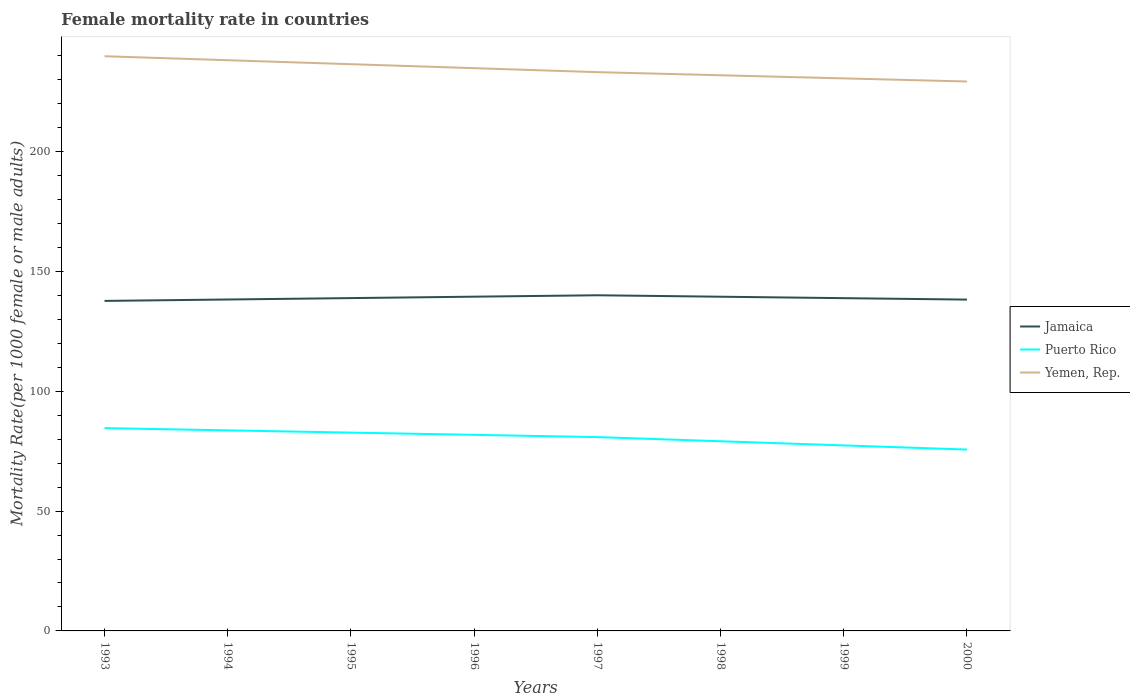Is the number of lines equal to the number of legend labels?
Give a very brief answer. Yes. Across all years, what is the maximum female mortality rate in Jamaica?
Ensure brevity in your answer.  137.72. In which year was the female mortality rate in Puerto Rico maximum?
Ensure brevity in your answer.  2000. What is the total female mortality rate in Jamaica in the graph?
Offer a very short reply. -0.54. What is the difference between the highest and the second highest female mortality rate in Jamaica?
Ensure brevity in your answer.  2.35. How many years are there in the graph?
Your answer should be very brief. 8. What is the difference between two consecutive major ticks on the Y-axis?
Provide a short and direct response. 50. Does the graph contain any zero values?
Provide a succinct answer. No. How many legend labels are there?
Offer a very short reply. 3. How are the legend labels stacked?
Your response must be concise. Vertical. What is the title of the graph?
Your answer should be very brief. Female mortality rate in countries. Does "Mexico" appear as one of the legend labels in the graph?
Your answer should be compact. No. What is the label or title of the X-axis?
Keep it short and to the point. Years. What is the label or title of the Y-axis?
Ensure brevity in your answer.  Mortality Rate(per 1000 female or male adults). What is the Mortality Rate(per 1000 female or male adults) of Jamaica in 1993?
Your answer should be compact. 137.72. What is the Mortality Rate(per 1000 female or male adults) in Puerto Rico in 1993?
Give a very brief answer. 84.63. What is the Mortality Rate(per 1000 female or male adults) of Yemen, Rep. in 1993?
Your response must be concise. 239.82. What is the Mortality Rate(per 1000 female or male adults) of Jamaica in 1994?
Your answer should be compact. 138.31. What is the Mortality Rate(per 1000 female or male adults) in Puerto Rico in 1994?
Give a very brief answer. 83.7. What is the Mortality Rate(per 1000 female or male adults) in Yemen, Rep. in 1994?
Offer a terse response. 238.16. What is the Mortality Rate(per 1000 female or male adults) in Jamaica in 1995?
Make the answer very short. 138.89. What is the Mortality Rate(per 1000 female or male adults) in Puerto Rico in 1995?
Your response must be concise. 82.76. What is the Mortality Rate(per 1000 female or male adults) of Yemen, Rep. in 1995?
Ensure brevity in your answer.  236.5. What is the Mortality Rate(per 1000 female or male adults) of Jamaica in 1996?
Offer a terse response. 139.48. What is the Mortality Rate(per 1000 female or male adults) in Puerto Rico in 1996?
Offer a very short reply. 81.82. What is the Mortality Rate(per 1000 female or male adults) of Yemen, Rep. in 1996?
Ensure brevity in your answer.  234.84. What is the Mortality Rate(per 1000 female or male adults) of Jamaica in 1997?
Your response must be concise. 140.07. What is the Mortality Rate(per 1000 female or male adults) of Puerto Rico in 1997?
Give a very brief answer. 80.89. What is the Mortality Rate(per 1000 female or male adults) of Yemen, Rep. in 1997?
Keep it short and to the point. 233.18. What is the Mortality Rate(per 1000 female or male adults) of Jamaica in 1998?
Offer a terse response. 139.47. What is the Mortality Rate(per 1000 female or male adults) in Puerto Rico in 1998?
Provide a short and direct response. 79.15. What is the Mortality Rate(per 1000 female or male adults) of Yemen, Rep. in 1998?
Provide a succinct answer. 231.88. What is the Mortality Rate(per 1000 female or male adults) in Jamaica in 1999?
Keep it short and to the point. 138.87. What is the Mortality Rate(per 1000 female or male adults) of Puerto Rico in 1999?
Your answer should be very brief. 77.42. What is the Mortality Rate(per 1000 female or male adults) of Yemen, Rep. in 1999?
Provide a succinct answer. 230.58. What is the Mortality Rate(per 1000 female or male adults) of Jamaica in 2000?
Ensure brevity in your answer.  138.26. What is the Mortality Rate(per 1000 female or male adults) of Puerto Rico in 2000?
Your response must be concise. 75.68. What is the Mortality Rate(per 1000 female or male adults) of Yemen, Rep. in 2000?
Offer a terse response. 229.28. Across all years, what is the maximum Mortality Rate(per 1000 female or male adults) of Jamaica?
Provide a short and direct response. 140.07. Across all years, what is the maximum Mortality Rate(per 1000 female or male adults) in Puerto Rico?
Make the answer very short. 84.63. Across all years, what is the maximum Mortality Rate(per 1000 female or male adults) in Yemen, Rep.?
Offer a very short reply. 239.82. Across all years, what is the minimum Mortality Rate(per 1000 female or male adults) in Jamaica?
Your answer should be compact. 137.72. Across all years, what is the minimum Mortality Rate(per 1000 female or male adults) in Puerto Rico?
Provide a short and direct response. 75.68. Across all years, what is the minimum Mortality Rate(per 1000 female or male adults) in Yemen, Rep.?
Ensure brevity in your answer.  229.28. What is the total Mortality Rate(per 1000 female or male adults) in Jamaica in the graph?
Your response must be concise. 1111.07. What is the total Mortality Rate(per 1000 female or male adults) in Puerto Rico in the graph?
Your answer should be compact. 646.04. What is the total Mortality Rate(per 1000 female or male adults) of Yemen, Rep. in the graph?
Make the answer very short. 1874.24. What is the difference between the Mortality Rate(per 1000 female or male adults) of Jamaica in 1993 and that in 1994?
Your answer should be very brief. -0.59. What is the difference between the Mortality Rate(per 1000 female or male adults) in Puerto Rico in 1993 and that in 1994?
Give a very brief answer. 0.94. What is the difference between the Mortality Rate(per 1000 female or male adults) in Yemen, Rep. in 1993 and that in 1994?
Provide a short and direct response. 1.66. What is the difference between the Mortality Rate(per 1000 female or male adults) in Jamaica in 1993 and that in 1995?
Ensure brevity in your answer.  -1.18. What is the difference between the Mortality Rate(per 1000 female or male adults) in Puerto Rico in 1993 and that in 1995?
Offer a terse response. 1.87. What is the difference between the Mortality Rate(per 1000 female or male adults) of Yemen, Rep. in 1993 and that in 1995?
Your response must be concise. 3.32. What is the difference between the Mortality Rate(per 1000 female or male adults) of Jamaica in 1993 and that in 1996?
Offer a terse response. -1.76. What is the difference between the Mortality Rate(per 1000 female or male adults) in Puerto Rico in 1993 and that in 1996?
Your answer should be compact. 2.81. What is the difference between the Mortality Rate(per 1000 female or male adults) of Yemen, Rep. in 1993 and that in 1996?
Your answer should be compact. 4.98. What is the difference between the Mortality Rate(per 1000 female or male adults) in Jamaica in 1993 and that in 1997?
Your response must be concise. -2.35. What is the difference between the Mortality Rate(per 1000 female or male adults) of Puerto Rico in 1993 and that in 1997?
Your answer should be compact. 3.75. What is the difference between the Mortality Rate(per 1000 female or male adults) of Yemen, Rep. in 1993 and that in 1997?
Ensure brevity in your answer.  6.64. What is the difference between the Mortality Rate(per 1000 female or male adults) of Jamaica in 1993 and that in 1998?
Your answer should be very brief. -1.75. What is the difference between the Mortality Rate(per 1000 female or male adults) in Puerto Rico in 1993 and that in 1998?
Provide a short and direct response. 5.48. What is the difference between the Mortality Rate(per 1000 female or male adults) in Yemen, Rep. in 1993 and that in 1998?
Keep it short and to the point. 7.94. What is the difference between the Mortality Rate(per 1000 female or male adults) in Jamaica in 1993 and that in 1999?
Keep it short and to the point. -1.15. What is the difference between the Mortality Rate(per 1000 female or male adults) of Puerto Rico in 1993 and that in 1999?
Give a very brief answer. 7.22. What is the difference between the Mortality Rate(per 1000 female or male adults) of Yemen, Rep. in 1993 and that in 1999?
Provide a succinct answer. 9.24. What is the difference between the Mortality Rate(per 1000 female or male adults) of Jamaica in 1993 and that in 2000?
Give a very brief answer. -0.54. What is the difference between the Mortality Rate(per 1000 female or male adults) in Puerto Rico in 1993 and that in 2000?
Your answer should be very brief. 8.95. What is the difference between the Mortality Rate(per 1000 female or male adults) in Yemen, Rep. in 1993 and that in 2000?
Give a very brief answer. 10.54. What is the difference between the Mortality Rate(per 1000 female or male adults) in Jamaica in 1994 and that in 1995?
Give a very brief answer. -0.59. What is the difference between the Mortality Rate(per 1000 female or male adults) in Puerto Rico in 1994 and that in 1995?
Provide a succinct answer. 0.94. What is the difference between the Mortality Rate(per 1000 female or male adults) in Yemen, Rep. in 1994 and that in 1995?
Your answer should be compact. 1.66. What is the difference between the Mortality Rate(per 1000 female or male adults) of Jamaica in 1994 and that in 1996?
Your answer should be compact. -1.18. What is the difference between the Mortality Rate(per 1000 female or male adults) in Puerto Rico in 1994 and that in 1996?
Make the answer very short. 1.87. What is the difference between the Mortality Rate(per 1000 female or male adults) in Yemen, Rep. in 1994 and that in 1996?
Offer a terse response. 3.32. What is the difference between the Mortality Rate(per 1000 female or male adults) in Jamaica in 1994 and that in 1997?
Offer a very short reply. -1.76. What is the difference between the Mortality Rate(per 1000 female or male adults) in Puerto Rico in 1994 and that in 1997?
Your answer should be compact. 2.81. What is the difference between the Mortality Rate(per 1000 female or male adults) of Yemen, Rep. in 1994 and that in 1997?
Ensure brevity in your answer.  4.98. What is the difference between the Mortality Rate(per 1000 female or male adults) of Jamaica in 1994 and that in 1998?
Ensure brevity in your answer.  -1.16. What is the difference between the Mortality Rate(per 1000 female or male adults) in Puerto Rico in 1994 and that in 1998?
Ensure brevity in your answer.  4.55. What is the difference between the Mortality Rate(per 1000 female or male adults) of Yemen, Rep. in 1994 and that in 1998?
Offer a terse response. 6.28. What is the difference between the Mortality Rate(per 1000 female or male adults) in Jamaica in 1994 and that in 1999?
Ensure brevity in your answer.  -0.56. What is the difference between the Mortality Rate(per 1000 female or male adults) of Puerto Rico in 1994 and that in 1999?
Provide a short and direct response. 6.28. What is the difference between the Mortality Rate(per 1000 female or male adults) in Yemen, Rep. in 1994 and that in 1999?
Your answer should be compact. 7.58. What is the difference between the Mortality Rate(per 1000 female or male adults) of Jamaica in 1994 and that in 2000?
Provide a succinct answer. 0.04. What is the difference between the Mortality Rate(per 1000 female or male adults) of Puerto Rico in 1994 and that in 2000?
Your response must be concise. 8.02. What is the difference between the Mortality Rate(per 1000 female or male adults) in Yemen, Rep. in 1994 and that in 2000?
Your answer should be very brief. 8.88. What is the difference between the Mortality Rate(per 1000 female or male adults) of Jamaica in 1995 and that in 1996?
Provide a succinct answer. -0.59. What is the difference between the Mortality Rate(per 1000 female or male adults) in Puerto Rico in 1995 and that in 1996?
Your answer should be compact. 0.94. What is the difference between the Mortality Rate(per 1000 female or male adults) of Yemen, Rep. in 1995 and that in 1996?
Make the answer very short. 1.66. What is the difference between the Mortality Rate(per 1000 female or male adults) in Jamaica in 1995 and that in 1997?
Provide a short and direct response. -1.18. What is the difference between the Mortality Rate(per 1000 female or male adults) in Puerto Rico in 1995 and that in 1997?
Offer a very short reply. 1.87. What is the difference between the Mortality Rate(per 1000 female or male adults) of Yemen, Rep. in 1995 and that in 1997?
Make the answer very short. 3.32. What is the difference between the Mortality Rate(per 1000 female or male adults) in Jamaica in 1995 and that in 1998?
Keep it short and to the point. -0.57. What is the difference between the Mortality Rate(per 1000 female or male adults) of Puerto Rico in 1995 and that in 1998?
Your response must be concise. 3.61. What is the difference between the Mortality Rate(per 1000 female or male adults) of Yemen, Rep. in 1995 and that in 1998?
Offer a terse response. 4.62. What is the difference between the Mortality Rate(per 1000 female or male adults) in Jamaica in 1995 and that in 1999?
Your response must be concise. 0.03. What is the difference between the Mortality Rate(per 1000 female or male adults) in Puerto Rico in 1995 and that in 1999?
Your answer should be compact. 5.34. What is the difference between the Mortality Rate(per 1000 female or male adults) in Yemen, Rep. in 1995 and that in 1999?
Your answer should be compact. 5.92. What is the difference between the Mortality Rate(per 1000 female or male adults) in Jamaica in 1995 and that in 2000?
Provide a succinct answer. 0.63. What is the difference between the Mortality Rate(per 1000 female or male adults) in Puerto Rico in 1995 and that in 2000?
Provide a short and direct response. 7.08. What is the difference between the Mortality Rate(per 1000 female or male adults) in Yemen, Rep. in 1995 and that in 2000?
Make the answer very short. 7.22. What is the difference between the Mortality Rate(per 1000 female or male adults) of Jamaica in 1996 and that in 1997?
Your answer should be very brief. -0.59. What is the difference between the Mortality Rate(per 1000 female or male adults) in Puerto Rico in 1996 and that in 1997?
Offer a very short reply. 0.94. What is the difference between the Mortality Rate(per 1000 female or male adults) in Yemen, Rep. in 1996 and that in 1997?
Provide a succinct answer. 1.66. What is the difference between the Mortality Rate(per 1000 female or male adults) of Jamaica in 1996 and that in 1998?
Your answer should be very brief. 0.01. What is the difference between the Mortality Rate(per 1000 female or male adults) of Puerto Rico in 1996 and that in 1998?
Your answer should be very brief. 2.67. What is the difference between the Mortality Rate(per 1000 female or male adults) of Yemen, Rep. in 1996 and that in 1998?
Your answer should be compact. 2.96. What is the difference between the Mortality Rate(per 1000 female or male adults) of Jamaica in 1996 and that in 1999?
Give a very brief answer. 0.62. What is the difference between the Mortality Rate(per 1000 female or male adults) of Puerto Rico in 1996 and that in 1999?
Keep it short and to the point. 4.41. What is the difference between the Mortality Rate(per 1000 female or male adults) in Yemen, Rep. in 1996 and that in 1999?
Your response must be concise. 4.26. What is the difference between the Mortality Rate(per 1000 female or male adults) in Jamaica in 1996 and that in 2000?
Make the answer very short. 1.22. What is the difference between the Mortality Rate(per 1000 female or male adults) of Puerto Rico in 1996 and that in 2000?
Your answer should be very brief. 6.14. What is the difference between the Mortality Rate(per 1000 female or male adults) of Yemen, Rep. in 1996 and that in 2000?
Provide a succinct answer. 5.57. What is the difference between the Mortality Rate(per 1000 female or male adults) of Jamaica in 1997 and that in 1998?
Provide a short and direct response. 0.6. What is the difference between the Mortality Rate(per 1000 female or male adults) in Puerto Rico in 1997 and that in 1998?
Ensure brevity in your answer.  1.74. What is the difference between the Mortality Rate(per 1000 female or male adults) of Yemen, Rep. in 1997 and that in 1998?
Offer a terse response. 1.3. What is the difference between the Mortality Rate(per 1000 female or male adults) of Jamaica in 1997 and that in 1999?
Your response must be concise. 1.2. What is the difference between the Mortality Rate(per 1000 female or male adults) in Puerto Rico in 1997 and that in 1999?
Your response must be concise. 3.47. What is the difference between the Mortality Rate(per 1000 female or male adults) of Yemen, Rep. in 1997 and that in 1999?
Your answer should be compact. 2.6. What is the difference between the Mortality Rate(per 1000 female or male adults) of Jamaica in 1997 and that in 2000?
Provide a short and direct response. 1.81. What is the difference between the Mortality Rate(per 1000 female or male adults) of Puerto Rico in 1997 and that in 2000?
Your response must be concise. 5.21. What is the difference between the Mortality Rate(per 1000 female or male adults) of Yemen, Rep. in 1997 and that in 2000?
Make the answer very short. 3.91. What is the difference between the Mortality Rate(per 1000 female or male adults) of Jamaica in 1998 and that in 1999?
Make the answer very short. 0.6. What is the difference between the Mortality Rate(per 1000 female or male adults) of Puerto Rico in 1998 and that in 1999?
Ensure brevity in your answer.  1.74. What is the difference between the Mortality Rate(per 1000 female or male adults) of Yemen, Rep. in 1998 and that in 1999?
Your answer should be compact. 1.3. What is the difference between the Mortality Rate(per 1000 female or male adults) of Jamaica in 1998 and that in 2000?
Your answer should be compact. 1.2. What is the difference between the Mortality Rate(per 1000 female or male adults) of Puerto Rico in 1998 and that in 2000?
Provide a short and direct response. 3.47. What is the difference between the Mortality Rate(per 1000 female or male adults) in Yemen, Rep. in 1998 and that in 2000?
Give a very brief answer. 2.6. What is the difference between the Mortality Rate(per 1000 female or male adults) of Jamaica in 1999 and that in 2000?
Your response must be concise. 0.6. What is the difference between the Mortality Rate(per 1000 female or male adults) in Puerto Rico in 1999 and that in 2000?
Offer a terse response. 1.74. What is the difference between the Mortality Rate(per 1000 female or male adults) in Yemen, Rep. in 1999 and that in 2000?
Offer a very short reply. 1.3. What is the difference between the Mortality Rate(per 1000 female or male adults) of Jamaica in 1993 and the Mortality Rate(per 1000 female or male adults) of Puerto Rico in 1994?
Provide a short and direct response. 54.02. What is the difference between the Mortality Rate(per 1000 female or male adults) of Jamaica in 1993 and the Mortality Rate(per 1000 female or male adults) of Yemen, Rep. in 1994?
Offer a terse response. -100.44. What is the difference between the Mortality Rate(per 1000 female or male adults) of Puerto Rico in 1993 and the Mortality Rate(per 1000 female or male adults) of Yemen, Rep. in 1994?
Provide a succinct answer. -153.53. What is the difference between the Mortality Rate(per 1000 female or male adults) in Jamaica in 1993 and the Mortality Rate(per 1000 female or male adults) in Puerto Rico in 1995?
Ensure brevity in your answer.  54.96. What is the difference between the Mortality Rate(per 1000 female or male adults) of Jamaica in 1993 and the Mortality Rate(per 1000 female or male adults) of Yemen, Rep. in 1995?
Provide a short and direct response. -98.78. What is the difference between the Mortality Rate(per 1000 female or male adults) in Puerto Rico in 1993 and the Mortality Rate(per 1000 female or male adults) in Yemen, Rep. in 1995?
Provide a short and direct response. -151.87. What is the difference between the Mortality Rate(per 1000 female or male adults) of Jamaica in 1993 and the Mortality Rate(per 1000 female or male adults) of Puerto Rico in 1996?
Your response must be concise. 55.9. What is the difference between the Mortality Rate(per 1000 female or male adults) in Jamaica in 1993 and the Mortality Rate(per 1000 female or male adults) in Yemen, Rep. in 1996?
Offer a terse response. -97.12. What is the difference between the Mortality Rate(per 1000 female or male adults) of Puerto Rico in 1993 and the Mortality Rate(per 1000 female or male adults) of Yemen, Rep. in 1996?
Offer a very short reply. -150.21. What is the difference between the Mortality Rate(per 1000 female or male adults) of Jamaica in 1993 and the Mortality Rate(per 1000 female or male adults) of Puerto Rico in 1997?
Your response must be concise. 56.83. What is the difference between the Mortality Rate(per 1000 female or male adults) in Jamaica in 1993 and the Mortality Rate(per 1000 female or male adults) in Yemen, Rep. in 1997?
Provide a short and direct response. -95.47. What is the difference between the Mortality Rate(per 1000 female or male adults) of Puerto Rico in 1993 and the Mortality Rate(per 1000 female or male adults) of Yemen, Rep. in 1997?
Keep it short and to the point. -148.55. What is the difference between the Mortality Rate(per 1000 female or male adults) of Jamaica in 1993 and the Mortality Rate(per 1000 female or male adults) of Puerto Rico in 1998?
Ensure brevity in your answer.  58.57. What is the difference between the Mortality Rate(per 1000 female or male adults) of Jamaica in 1993 and the Mortality Rate(per 1000 female or male adults) of Yemen, Rep. in 1998?
Give a very brief answer. -94.16. What is the difference between the Mortality Rate(per 1000 female or male adults) in Puerto Rico in 1993 and the Mortality Rate(per 1000 female or male adults) in Yemen, Rep. in 1998?
Offer a very short reply. -147.25. What is the difference between the Mortality Rate(per 1000 female or male adults) in Jamaica in 1993 and the Mortality Rate(per 1000 female or male adults) in Puerto Rico in 1999?
Keep it short and to the point. 60.3. What is the difference between the Mortality Rate(per 1000 female or male adults) in Jamaica in 1993 and the Mortality Rate(per 1000 female or male adults) in Yemen, Rep. in 1999?
Offer a very short reply. -92.86. What is the difference between the Mortality Rate(per 1000 female or male adults) of Puerto Rico in 1993 and the Mortality Rate(per 1000 female or male adults) of Yemen, Rep. in 1999?
Your answer should be very brief. -145.94. What is the difference between the Mortality Rate(per 1000 female or male adults) of Jamaica in 1993 and the Mortality Rate(per 1000 female or male adults) of Puerto Rico in 2000?
Provide a short and direct response. 62.04. What is the difference between the Mortality Rate(per 1000 female or male adults) of Jamaica in 1993 and the Mortality Rate(per 1000 female or male adults) of Yemen, Rep. in 2000?
Provide a short and direct response. -91.56. What is the difference between the Mortality Rate(per 1000 female or male adults) in Puerto Rico in 1993 and the Mortality Rate(per 1000 female or male adults) in Yemen, Rep. in 2000?
Ensure brevity in your answer.  -144.64. What is the difference between the Mortality Rate(per 1000 female or male adults) of Jamaica in 1994 and the Mortality Rate(per 1000 female or male adults) of Puerto Rico in 1995?
Keep it short and to the point. 55.55. What is the difference between the Mortality Rate(per 1000 female or male adults) in Jamaica in 1994 and the Mortality Rate(per 1000 female or male adults) in Yemen, Rep. in 1995?
Offer a very short reply. -98.19. What is the difference between the Mortality Rate(per 1000 female or male adults) in Puerto Rico in 1994 and the Mortality Rate(per 1000 female or male adults) in Yemen, Rep. in 1995?
Keep it short and to the point. -152.8. What is the difference between the Mortality Rate(per 1000 female or male adults) of Jamaica in 1994 and the Mortality Rate(per 1000 female or male adults) of Puerto Rico in 1996?
Offer a terse response. 56.48. What is the difference between the Mortality Rate(per 1000 female or male adults) of Jamaica in 1994 and the Mortality Rate(per 1000 female or male adults) of Yemen, Rep. in 1996?
Provide a short and direct response. -96.54. What is the difference between the Mortality Rate(per 1000 female or male adults) in Puerto Rico in 1994 and the Mortality Rate(per 1000 female or male adults) in Yemen, Rep. in 1996?
Your response must be concise. -151.14. What is the difference between the Mortality Rate(per 1000 female or male adults) in Jamaica in 1994 and the Mortality Rate(per 1000 female or male adults) in Puerto Rico in 1997?
Ensure brevity in your answer.  57.42. What is the difference between the Mortality Rate(per 1000 female or male adults) in Jamaica in 1994 and the Mortality Rate(per 1000 female or male adults) in Yemen, Rep. in 1997?
Give a very brief answer. -94.88. What is the difference between the Mortality Rate(per 1000 female or male adults) of Puerto Rico in 1994 and the Mortality Rate(per 1000 female or male adults) of Yemen, Rep. in 1997?
Your response must be concise. -149.49. What is the difference between the Mortality Rate(per 1000 female or male adults) in Jamaica in 1994 and the Mortality Rate(per 1000 female or male adults) in Puerto Rico in 1998?
Ensure brevity in your answer.  59.16. What is the difference between the Mortality Rate(per 1000 female or male adults) in Jamaica in 1994 and the Mortality Rate(per 1000 female or male adults) in Yemen, Rep. in 1998?
Provide a short and direct response. -93.58. What is the difference between the Mortality Rate(per 1000 female or male adults) in Puerto Rico in 1994 and the Mortality Rate(per 1000 female or male adults) in Yemen, Rep. in 1998?
Provide a short and direct response. -148.18. What is the difference between the Mortality Rate(per 1000 female or male adults) of Jamaica in 1994 and the Mortality Rate(per 1000 female or male adults) of Puerto Rico in 1999?
Provide a succinct answer. 60.89. What is the difference between the Mortality Rate(per 1000 female or male adults) of Jamaica in 1994 and the Mortality Rate(per 1000 female or male adults) of Yemen, Rep. in 1999?
Provide a succinct answer. -92.27. What is the difference between the Mortality Rate(per 1000 female or male adults) in Puerto Rico in 1994 and the Mortality Rate(per 1000 female or male adults) in Yemen, Rep. in 1999?
Keep it short and to the point. -146.88. What is the difference between the Mortality Rate(per 1000 female or male adults) in Jamaica in 1994 and the Mortality Rate(per 1000 female or male adults) in Puerto Rico in 2000?
Give a very brief answer. 62.63. What is the difference between the Mortality Rate(per 1000 female or male adults) in Jamaica in 1994 and the Mortality Rate(per 1000 female or male adults) in Yemen, Rep. in 2000?
Offer a very short reply. -90.97. What is the difference between the Mortality Rate(per 1000 female or male adults) of Puerto Rico in 1994 and the Mortality Rate(per 1000 female or male adults) of Yemen, Rep. in 2000?
Your response must be concise. -145.58. What is the difference between the Mortality Rate(per 1000 female or male adults) in Jamaica in 1995 and the Mortality Rate(per 1000 female or male adults) in Puerto Rico in 1996?
Provide a succinct answer. 57.07. What is the difference between the Mortality Rate(per 1000 female or male adults) of Jamaica in 1995 and the Mortality Rate(per 1000 female or male adults) of Yemen, Rep. in 1996?
Keep it short and to the point. -95.95. What is the difference between the Mortality Rate(per 1000 female or male adults) in Puerto Rico in 1995 and the Mortality Rate(per 1000 female or male adults) in Yemen, Rep. in 1996?
Give a very brief answer. -152.08. What is the difference between the Mortality Rate(per 1000 female or male adults) of Jamaica in 1995 and the Mortality Rate(per 1000 female or male adults) of Puerto Rico in 1997?
Offer a very short reply. 58.01. What is the difference between the Mortality Rate(per 1000 female or male adults) of Jamaica in 1995 and the Mortality Rate(per 1000 female or male adults) of Yemen, Rep. in 1997?
Your answer should be very brief. -94.29. What is the difference between the Mortality Rate(per 1000 female or male adults) of Puerto Rico in 1995 and the Mortality Rate(per 1000 female or male adults) of Yemen, Rep. in 1997?
Give a very brief answer. -150.42. What is the difference between the Mortality Rate(per 1000 female or male adults) of Jamaica in 1995 and the Mortality Rate(per 1000 female or male adults) of Puerto Rico in 1998?
Offer a very short reply. 59.74. What is the difference between the Mortality Rate(per 1000 female or male adults) in Jamaica in 1995 and the Mortality Rate(per 1000 female or male adults) in Yemen, Rep. in 1998?
Provide a short and direct response. -92.99. What is the difference between the Mortality Rate(per 1000 female or male adults) of Puerto Rico in 1995 and the Mortality Rate(per 1000 female or male adults) of Yemen, Rep. in 1998?
Your answer should be compact. -149.12. What is the difference between the Mortality Rate(per 1000 female or male adults) in Jamaica in 1995 and the Mortality Rate(per 1000 female or male adults) in Puerto Rico in 1999?
Give a very brief answer. 61.48. What is the difference between the Mortality Rate(per 1000 female or male adults) of Jamaica in 1995 and the Mortality Rate(per 1000 female or male adults) of Yemen, Rep. in 1999?
Provide a succinct answer. -91.69. What is the difference between the Mortality Rate(per 1000 female or male adults) of Puerto Rico in 1995 and the Mortality Rate(per 1000 female or male adults) of Yemen, Rep. in 1999?
Give a very brief answer. -147.82. What is the difference between the Mortality Rate(per 1000 female or male adults) of Jamaica in 1995 and the Mortality Rate(per 1000 female or male adults) of Puerto Rico in 2000?
Your answer should be very brief. 63.21. What is the difference between the Mortality Rate(per 1000 female or male adults) in Jamaica in 1995 and the Mortality Rate(per 1000 female or male adults) in Yemen, Rep. in 2000?
Ensure brevity in your answer.  -90.38. What is the difference between the Mortality Rate(per 1000 female or male adults) of Puerto Rico in 1995 and the Mortality Rate(per 1000 female or male adults) of Yemen, Rep. in 2000?
Keep it short and to the point. -146.52. What is the difference between the Mortality Rate(per 1000 female or male adults) of Jamaica in 1996 and the Mortality Rate(per 1000 female or male adults) of Puerto Rico in 1997?
Your response must be concise. 58.6. What is the difference between the Mortality Rate(per 1000 female or male adults) of Jamaica in 1996 and the Mortality Rate(per 1000 female or male adults) of Yemen, Rep. in 1997?
Your response must be concise. -93.7. What is the difference between the Mortality Rate(per 1000 female or male adults) of Puerto Rico in 1996 and the Mortality Rate(per 1000 female or male adults) of Yemen, Rep. in 1997?
Offer a very short reply. -151.36. What is the difference between the Mortality Rate(per 1000 female or male adults) in Jamaica in 1996 and the Mortality Rate(per 1000 female or male adults) in Puerto Rico in 1998?
Keep it short and to the point. 60.33. What is the difference between the Mortality Rate(per 1000 female or male adults) of Jamaica in 1996 and the Mortality Rate(per 1000 female or male adults) of Yemen, Rep. in 1998?
Offer a very short reply. -92.4. What is the difference between the Mortality Rate(per 1000 female or male adults) in Puerto Rico in 1996 and the Mortality Rate(per 1000 female or male adults) in Yemen, Rep. in 1998?
Provide a succinct answer. -150.06. What is the difference between the Mortality Rate(per 1000 female or male adults) in Jamaica in 1996 and the Mortality Rate(per 1000 female or male adults) in Puerto Rico in 1999?
Offer a terse response. 62.07. What is the difference between the Mortality Rate(per 1000 female or male adults) in Jamaica in 1996 and the Mortality Rate(per 1000 female or male adults) in Yemen, Rep. in 1999?
Offer a very short reply. -91.1. What is the difference between the Mortality Rate(per 1000 female or male adults) in Puerto Rico in 1996 and the Mortality Rate(per 1000 female or male adults) in Yemen, Rep. in 1999?
Offer a very short reply. -148.76. What is the difference between the Mortality Rate(per 1000 female or male adults) of Jamaica in 1996 and the Mortality Rate(per 1000 female or male adults) of Puerto Rico in 2000?
Offer a terse response. 63.8. What is the difference between the Mortality Rate(per 1000 female or male adults) in Jamaica in 1996 and the Mortality Rate(per 1000 female or male adults) in Yemen, Rep. in 2000?
Your answer should be very brief. -89.8. What is the difference between the Mortality Rate(per 1000 female or male adults) of Puerto Rico in 1996 and the Mortality Rate(per 1000 female or male adults) of Yemen, Rep. in 2000?
Make the answer very short. -147.45. What is the difference between the Mortality Rate(per 1000 female or male adults) of Jamaica in 1997 and the Mortality Rate(per 1000 female or male adults) of Puerto Rico in 1998?
Your answer should be very brief. 60.92. What is the difference between the Mortality Rate(per 1000 female or male adults) in Jamaica in 1997 and the Mortality Rate(per 1000 female or male adults) in Yemen, Rep. in 1998?
Your answer should be very brief. -91.81. What is the difference between the Mortality Rate(per 1000 female or male adults) of Puerto Rico in 1997 and the Mortality Rate(per 1000 female or male adults) of Yemen, Rep. in 1998?
Give a very brief answer. -151. What is the difference between the Mortality Rate(per 1000 female or male adults) of Jamaica in 1997 and the Mortality Rate(per 1000 female or male adults) of Puerto Rico in 1999?
Keep it short and to the point. 62.66. What is the difference between the Mortality Rate(per 1000 female or male adults) in Jamaica in 1997 and the Mortality Rate(per 1000 female or male adults) in Yemen, Rep. in 1999?
Provide a short and direct response. -90.51. What is the difference between the Mortality Rate(per 1000 female or male adults) in Puerto Rico in 1997 and the Mortality Rate(per 1000 female or male adults) in Yemen, Rep. in 1999?
Make the answer very short. -149.69. What is the difference between the Mortality Rate(per 1000 female or male adults) in Jamaica in 1997 and the Mortality Rate(per 1000 female or male adults) in Puerto Rico in 2000?
Keep it short and to the point. 64.39. What is the difference between the Mortality Rate(per 1000 female or male adults) of Jamaica in 1997 and the Mortality Rate(per 1000 female or male adults) of Yemen, Rep. in 2000?
Offer a terse response. -89.21. What is the difference between the Mortality Rate(per 1000 female or male adults) in Puerto Rico in 1997 and the Mortality Rate(per 1000 female or male adults) in Yemen, Rep. in 2000?
Your answer should be very brief. -148.39. What is the difference between the Mortality Rate(per 1000 female or male adults) of Jamaica in 1998 and the Mortality Rate(per 1000 female or male adults) of Puerto Rico in 1999?
Make the answer very short. 62.05. What is the difference between the Mortality Rate(per 1000 female or male adults) of Jamaica in 1998 and the Mortality Rate(per 1000 female or male adults) of Yemen, Rep. in 1999?
Ensure brevity in your answer.  -91.11. What is the difference between the Mortality Rate(per 1000 female or male adults) of Puerto Rico in 1998 and the Mortality Rate(per 1000 female or male adults) of Yemen, Rep. in 1999?
Offer a very short reply. -151.43. What is the difference between the Mortality Rate(per 1000 female or male adults) in Jamaica in 1998 and the Mortality Rate(per 1000 female or male adults) in Puerto Rico in 2000?
Ensure brevity in your answer.  63.79. What is the difference between the Mortality Rate(per 1000 female or male adults) of Jamaica in 1998 and the Mortality Rate(per 1000 female or male adults) of Yemen, Rep. in 2000?
Provide a succinct answer. -89.81. What is the difference between the Mortality Rate(per 1000 female or male adults) of Puerto Rico in 1998 and the Mortality Rate(per 1000 female or male adults) of Yemen, Rep. in 2000?
Provide a short and direct response. -150.13. What is the difference between the Mortality Rate(per 1000 female or male adults) of Jamaica in 1999 and the Mortality Rate(per 1000 female or male adults) of Puerto Rico in 2000?
Offer a very short reply. 63.19. What is the difference between the Mortality Rate(per 1000 female or male adults) of Jamaica in 1999 and the Mortality Rate(per 1000 female or male adults) of Yemen, Rep. in 2000?
Ensure brevity in your answer.  -90.41. What is the difference between the Mortality Rate(per 1000 female or male adults) of Puerto Rico in 1999 and the Mortality Rate(per 1000 female or male adults) of Yemen, Rep. in 2000?
Your response must be concise. -151.86. What is the average Mortality Rate(per 1000 female or male adults) in Jamaica per year?
Your response must be concise. 138.88. What is the average Mortality Rate(per 1000 female or male adults) in Puerto Rico per year?
Keep it short and to the point. 80.76. What is the average Mortality Rate(per 1000 female or male adults) in Yemen, Rep. per year?
Your response must be concise. 234.28. In the year 1993, what is the difference between the Mortality Rate(per 1000 female or male adults) in Jamaica and Mortality Rate(per 1000 female or male adults) in Puerto Rico?
Your answer should be compact. 53.08. In the year 1993, what is the difference between the Mortality Rate(per 1000 female or male adults) in Jamaica and Mortality Rate(per 1000 female or male adults) in Yemen, Rep.?
Ensure brevity in your answer.  -102.1. In the year 1993, what is the difference between the Mortality Rate(per 1000 female or male adults) of Puerto Rico and Mortality Rate(per 1000 female or male adults) of Yemen, Rep.?
Provide a short and direct response. -155.18. In the year 1994, what is the difference between the Mortality Rate(per 1000 female or male adults) of Jamaica and Mortality Rate(per 1000 female or male adults) of Puerto Rico?
Your response must be concise. 54.61. In the year 1994, what is the difference between the Mortality Rate(per 1000 female or male adults) in Jamaica and Mortality Rate(per 1000 female or male adults) in Yemen, Rep.?
Your response must be concise. -99.85. In the year 1994, what is the difference between the Mortality Rate(per 1000 female or male adults) in Puerto Rico and Mortality Rate(per 1000 female or male adults) in Yemen, Rep.?
Keep it short and to the point. -154.46. In the year 1995, what is the difference between the Mortality Rate(per 1000 female or male adults) in Jamaica and Mortality Rate(per 1000 female or male adults) in Puerto Rico?
Your response must be concise. 56.13. In the year 1995, what is the difference between the Mortality Rate(per 1000 female or male adults) in Jamaica and Mortality Rate(per 1000 female or male adults) in Yemen, Rep.?
Provide a succinct answer. -97.61. In the year 1995, what is the difference between the Mortality Rate(per 1000 female or male adults) of Puerto Rico and Mortality Rate(per 1000 female or male adults) of Yemen, Rep.?
Make the answer very short. -153.74. In the year 1996, what is the difference between the Mortality Rate(per 1000 female or male adults) of Jamaica and Mortality Rate(per 1000 female or male adults) of Puerto Rico?
Keep it short and to the point. 57.66. In the year 1996, what is the difference between the Mortality Rate(per 1000 female or male adults) of Jamaica and Mortality Rate(per 1000 female or male adults) of Yemen, Rep.?
Give a very brief answer. -95.36. In the year 1996, what is the difference between the Mortality Rate(per 1000 female or male adults) of Puerto Rico and Mortality Rate(per 1000 female or male adults) of Yemen, Rep.?
Provide a short and direct response. -153.02. In the year 1997, what is the difference between the Mortality Rate(per 1000 female or male adults) of Jamaica and Mortality Rate(per 1000 female or male adults) of Puerto Rico?
Provide a succinct answer. 59.19. In the year 1997, what is the difference between the Mortality Rate(per 1000 female or male adults) in Jamaica and Mortality Rate(per 1000 female or male adults) in Yemen, Rep.?
Offer a terse response. -93.11. In the year 1997, what is the difference between the Mortality Rate(per 1000 female or male adults) in Puerto Rico and Mortality Rate(per 1000 female or male adults) in Yemen, Rep.?
Give a very brief answer. -152.3. In the year 1998, what is the difference between the Mortality Rate(per 1000 female or male adults) of Jamaica and Mortality Rate(per 1000 female or male adults) of Puerto Rico?
Provide a short and direct response. 60.32. In the year 1998, what is the difference between the Mortality Rate(per 1000 female or male adults) of Jamaica and Mortality Rate(per 1000 female or male adults) of Yemen, Rep.?
Your answer should be compact. -92.41. In the year 1998, what is the difference between the Mortality Rate(per 1000 female or male adults) in Puerto Rico and Mortality Rate(per 1000 female or male adults) in Yemen, Rep.?
Your response must be concise. -152.73. In the year 1999, what is the difference between the Mortality Rate(per 1000 female or male adults) of Jamaica and Mortality Rate(per 1000 female or male adults) of Puerto Rico?
Keep it short and to the point. 61.45. In the year 1999, what is the difference between the Mortality Rate(per 1000 female or male adults) of Jamaica and Mortality Rate(per 1000 female or male adults) of Yemen, Rep.?
Ensure brevity in your answer.  -91.71. In the year 1999, what is the difference between the Mortality Rate(per 1000 female or male adults) in Puerto Rico and Mortality Rate(per 1000 female or male adults) in Yemen, Rep.?
Your response must be concise. -153.16. In the year 2000, what is the difference between the Mortality Rate(per 1000 female or male adults) of Jamaica and Mortality Rate(per 1000 female or male adults) of Puerto Rico?
Make the answer very short. 62.58. In the year 2000, what is the difference between the Mortality Rate(per 1000 female or male adults) in Jamaica and Mortality Rate(per 1000 female or male adults) in Yemen, Rep.?
Make the answer very short. -91.01. In the year 2000, what is the difference between the Mortality Rate(per 1000 female or male adults) of Puerto Rico and Mortality Rate(per 1000 female or male adults) of Yemen, Rep.?
Ensure brevity in your answer.  -153.6. What is the ratio of the Mortality Rate(per 1000 female or male adults) of Jamaica in 1993 to that in 1994?
Offer a terse response. 1. What is the ratio of the Mortality Rate(per 1000 female or male adults) of Puerto Rico in 1993 to that in 1994?
Offer a terse response. 1.01. What is the ratio of the Mortality Rate(per 1000 female or male adults) in Puerto Rico in 1993 to that in 1995?
Provide a short and direct response. 1.02. What is the ratio of the Mortality Rate(per 1000 female or male adults) of Jamaica in 1993 to that in 1996?
Your answer should be very brief. 0.99. What is the ratio of the Mortality Rate(per 1000 female or male adults) in Puerto Rico in 1993 to that in 1996?
Keep it short and to the point. 1.03. What is the ratio of the Mortality Rate(per 1000 female or male adults) of Yemen, Rep. in 1993 to that in 1996?
Make the answer very short. 1.02. What is the ratio of the Mortality Rate(per 1000 female or male adults) in Jamaica in 1993 to that in 1997?
Give a very brief answer. 0.98. What is the ratio of the Mortality Rate(per 1000 female or male adults) in Puerto Rico in 1993 to that in 1997?
Provide a succinct answer. 1.05. What is the ratio of the Mortality Rate(per 1000 female or male adults) of Yemen, Rep. in 1993 to that in 1997?
Offer a terse response. 1.03. What is the ratio of the Mortality Rate(per 1000 female or male adults) of Jamaica in 1993 to that in 1998?
Your answer should be very brief. 0.99. What is the ratio of the Mortality Rate(per 1000 female or male adults) of Puerto Rico in 1993 to that in 1998?
Your response must be concise. 1.07. What is the ratio of the Mortality Rate(per 1000 female or male adults) of Yemen, Rep. in 1993 to that in 1998?
Offer a terse response. 1.03. What is the ratio of the Mortality Rate(per 1000 female or male adults) in Jamaica in 1993 to that in 1999?
Provide a short and direct response. 0.99. What is the ratio of the Mortality Rate(per 1000 female or male adults) of Puerto Rico in 1993 to that in 1999?
Make the answer very short. 1.09. What is the ratio of the Mortality Rate(per 1000 female or male adults) of Yemen, Rep. in 1993 to that in 1999?
Ensure brevity in your answer.  1.04. What is the ratio of the Mortality Rate(per 1000 female or male adults) of Jamaica in 1993 to that in 2000?
Make the answer very short. 1. What is the ratio of the Mortality Rate(per 1000 female or male adults) of Puerto Rico in 1993 to that in 2000?
Your response must be concise. 1.12. What is the ratio of the Mortality Rate(per 1000 female or male adults) of Yemen, Rep. in 1993 to that in 2000?
Provide a short and direct response. 1.05. What is the ratio of the Mortality Rate(per 1000 female or male adults) in Jamaica in 1994 to that in 1995?
Make the answer very short. 1. What is the ratio of the Mortality Rate(per 1000 female or male adults) in Puerto Rico in 1994 to that in 1995?
Make the answer very short. 1.01. What is the ratio of the Mortality Rate(per 1000 female or male adults) of Jamaica in 1994 to that in 1996?
Offer a very short reply. 0.99. What is the ratio of the Mortality Rate(per 1000 female or male adults) in Puerto Rico in 1994 to that in 1996?
Your response must be concise. 1.02. What is the ratio of the Mortality Rate(per 1000 female or male adults) in Yemen, Rep. in 1994 to that in 1996?
Make the answer very short. 1.01. What is the ratio of the Mortality Rate(per 1000 female or male adults) in Jamaica in 1994 to that in 1997?
Offer a very short reply. 0.99. What is the ratio of the Mortality Rate(per 1000 female or male adults) of Puerto Rico in 1994 to that in 1997?
Make the answer very short. 1.03. What is the ratio of the Mortality Rate(per 1000 female or male adults) of Yemen, Rep. in 1994 to that in 1997?
Offer a terse response. 1.02. What is the ratio of the Mortality Rate(per 1000 female or male adults) in Puerto Rico in 1994 to that in 1998?
Your response must be concise. 1.06. What is the ratio of the Mortality Rate(per 1000 female or male adults) of Yemen, Rep. in 1994 to that in 1998?
Your answer should be compact. 1.03. What is the ratio of the Mortality Rate(per 1000 female or male adults) in Puerto Rico in 1994 to that in 1999?
Your answer should be very brief. 1.08. What is the ratio of the Mortality Rate(per 1000 female or male adults) of Yemen, Rep. in 1994 to that in 1999?
Your answer should be very brief. 1.03. What is the ratio of the Mortality Rate(per 1000 female or male adults) in Jamaica in 1994 to that in 2000?
Ensure brevity in your answer.  1. What is the ratio of the Mortality Rate(per 1000 female or male adults) in Puerto Rico in 1994 to that in 2000?
Make the answer very short. 1.11. What is the ratio of the Mortality Rate(per 1000 female or male adults) of Yemen, Rep. in 1994 to that in 2000?
Your response must be concise. 1.04. What is the ratio of the Mortality Rate(per 1000 female or male adults) of Puerto Rico in 1995 to that in 1996?
Your response must be concise. 1.01. What is the ratio of the Mortality Rate(per 1000 female or male adults) of Yemen, Rep. in 1995 to that in 1996?
Your response must be concise. 1.01. What is the ratio of the Mortality Rate(per 1000 female or male adults) of Jamaica in 1995 to that in 1997?
Offer a terse response. 0.99. What is the ratio of the Mortality Rate(per 1000 female or male adults) of Puerto Rico in 1995 to that in 1997?
Ensure brevity in your answer.  1.02. What is the ratio of the Mortality Rate(per 1000 female or male adults) in Yemen, Rep. in 1995 to that in 1997?
Keep it short and to the point. 1.01. What is the ratio of the Mortality Rate(per 1000 female or male adults) of Jamaica in 1995 to that in 1998?
Provide a succinct answer. 1. What is the ratio of the Mortality Rate(per 1000 female or male adults) in Puerto Rico in 1995 to that in 1998?
Your response must be concise. 1.05. What is the ratio of the Mortality Rate(per 1000 female or male adults) of Yemen, Rep. in 1995 to that in 1998?
Provide a succinct answer. 1.02. What is the ratio of the Mortality Rate(per 1000 female or male adults) in Jamaica in 1995 to that in 1999?
Offer a terse response. 1. What is the ratio of the Mortality Rate(per 1000 female or male adults) in Puerto Rico in 1995 to that in 1999?
Make the answer very short. 1.07. What is the ratio of the Mortality Rate(per 1000 female or male adults) in Yemen, Rep. in 1995 to that in 1999?
Ensure brevity in your answer.  1.03. What is the ratio of the Mortality Rate(per 1000 female or male adults) of Jamaica in 1995 to that in 2000?
Offer a very short reply. 1. What is the ratio of the Mortality Rate(per 1000 female or male adults) in Puerto Rico in 1995 to that in 2000?
Provide a short and direct response. 1.09. What is the ratio of the Mortality Rate(per 1000 female or male adults) of Yemen, Rep. in 1995 to that in 2000?
Provide a short and direct response. 1.03. What is the ratio of the Mortality Rate(per 1000 female or male adults) in Puerto Rico in 1996 to that in 1997?
Make the answer very short. 1.01. What is the ratio of the Mortality Rate(per 1000 female or male adults) in Yemen, Rep. in 1996 to that in 1997?
Provide a short and direct response. 1.01. What is the ratio of the Mortality Rate(per 1000 female or male adults) of Puerto Rico in 1996 to that in 1998?
Your response must be concise. 1.03. What is the ratio of the Mortality Rate(per 1000 female or male adults) in Yemen, Rep. in 1996 to that in 1998?
Provide a short and direct response. 1.01. What is the ratio of the Mortality Rate(per 1000 female or male adults) in Jamaica in 1996 to that in 1999?
Offer a terse response. 1. What is the ratio of the Mortality Rate(per 1000 female or male adults) in Puerto Rico in 1996 to that in 1999?
Provide a succinct answer. 1.06. What is the ratio of the Mortality Rate(per 1000 female or male adults) in Yemen, Rep. in 1996 to that in 1999?
Provide a succinct answer. 1.02. What is the ratio of the Mortality Rate(per 1000 female or male adults) of Jamaica in 1996 to that in 2000?
Keep it short and to the point. 1.01. What is the ratio of the Mortality Rate(per 1000 female or male adults) of Puerto Rico in 1996 to that in 2000?
Offer a terse response. 1.08. What is the ratio of the Mortality Rate(per 1000 female or male adults) of Yemen, Rep. in 1996 to that in 2000?
Your response must be concise. 1.02. What is the ratio of the Mortality Rate(per 1000 female or male adults) of Puerto Rico in 1997 to that in 1998?
Give a very brief answer. 1.02. What is the ratio of the Mortality Rate(per 1000 female or male adults) in Yemen, Rep. in 1997 to that in 1998?
Your response must be concise. 1.01. What is the ratio of the Mortality Rate(per 1000 female or male adults) of Jamaica in 1997 to that in 1999?
Make the answer very short. 1.01. What is the ratio of the Mortality Rate(per 1000 female or male adults) in Puerto Rico in 1997 to that in 1999?
Your answer should be very brief. 1.04. What is the ratio of the Mortality Rate(per 1000 female or male adults) in Yemen, Rep. in 1997 to that in 1999?
Your answer should be very brief. 1.01. What is the ratio of the Mortality Rate(per 1000 female or male adults) of Jamaica in 1997 to that in 2000?
Offer a terse response. 1.01. What is the ratio of the Mortality Rate(per 1000 female or male adults) of Puerto Rico in 1997 to that in 2000?
Give a very brief answer. 1.07. What is the ratio of the Mortality Rate(per 1000 female or male adults) of Yemen, Rep. in 1997 to that in 2000?
Keep it short and to the point. 1.02. What is the ratio of the Mortality Rate(per 1000 female or male adults) of Puerto Rico in 1998 to that in 1999?
Provide a short and direct response. 1.02. What is the ratio of the Mortality Rate(per 1000 female or male adults) of Yemen, Rep. in 1998 to that in 1999?
Your answer should be compact. 1.01. What is the ratio of the Mortality Rate(per 1000 female or male adults) in Jamaica in 1998 to that in 2000?
Ensure brevity in your answer.  1.01. What is the ratio of the Mortality Rate(per 1000 female or male adults) in Puerto Rico in 1998 to that in 2000?
Your response must be concise. 1.05. What is the ratio of the Mortality Rate(per 1000 female or male adults) of Yemen, Rep. in 1998 to that in 2000?
Offer a very short reply. 1.01. What is the ratio of the Mortality Rate(per 1000 female or male adults) of Jamaica in 1999 to that in 2000?
Offer a terse response. 1. What is the ratio of the Mortality Rate(per 1000 female or male adults) of Puerto Rico in 1999 to that in 2000?
Your answer should be compact. 1.02. What is the difference between the highest and the second highest Mortality Rate(per 1000 female or male adults) in Jamaica?
Offer a very short reply. 0.59. What is the difference between the highest and the second highest Mortality Rate(per 1000 female or male adults) of Puerto Rico?
Your response must be concise. 0.94. What is the difference between the highest and the second highest Mortality Rate(per 1000 female or male adults) in Yemen, Rep.?
Offer a terse response. 1.66. What is the difference between the highest and the lowest Mortality Rate(per 1000 female or male adults) of Jamaica?
Your response must be concise. 2.35. What is the difference between the highest and the lowest Mortality Rate(per 1000 female or male adults) in Puerto Rico?
Offer a very short reply. 8.95. What is the difference between the highest and the lowest Mortality Rate(per 1000 female or male adults) in Yemen, Rep.?
Provide a succinct answer. 10.54. 